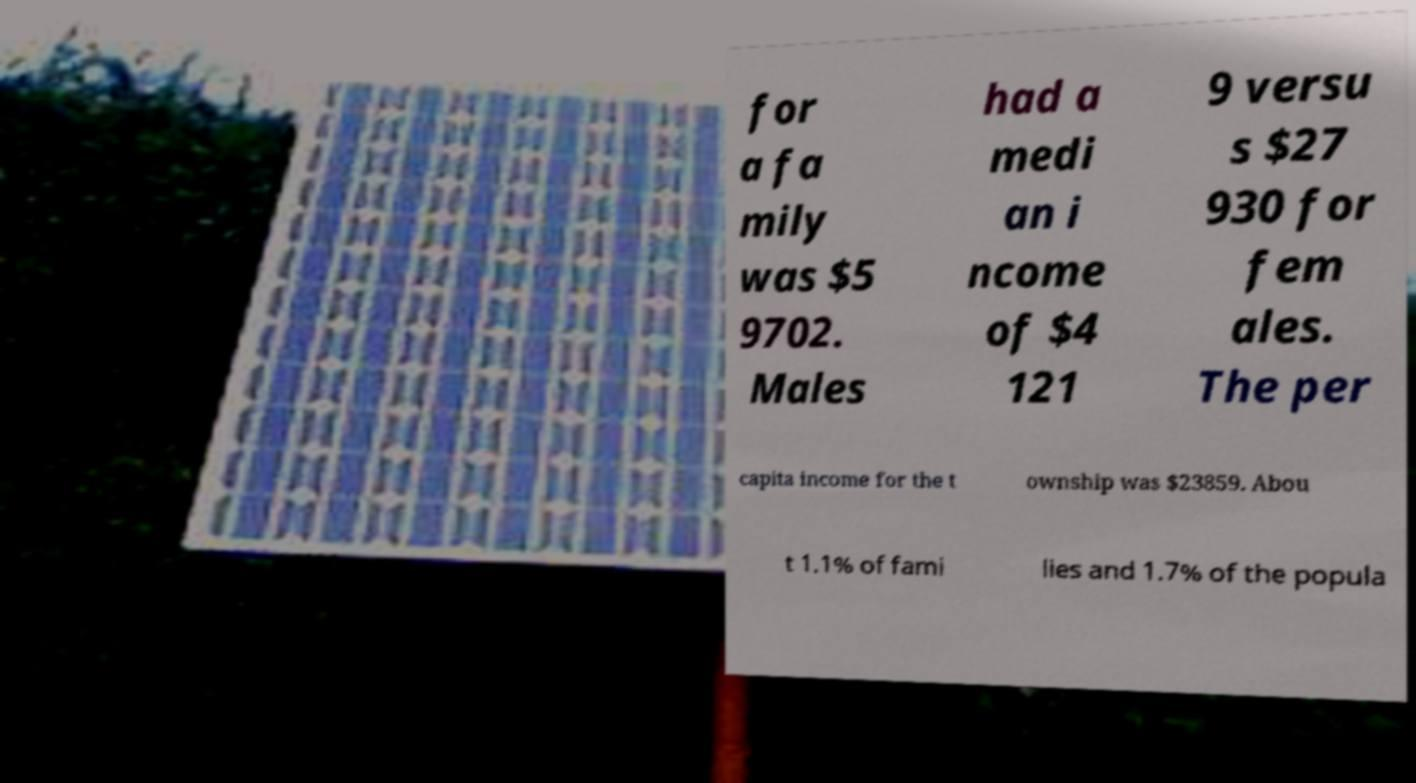Can you read and provide the text displayed in the image?This photo seems to have some interesting text. Can you extract and type it out for me? for a fa mily was $5 9702. Males had a medi an i ncome of $4 121 9 versu s $27 930 for fem ales. The per capita income for the t ownship was $23859. Abou t 1.1% of fami lies and 1.7% of the popula 